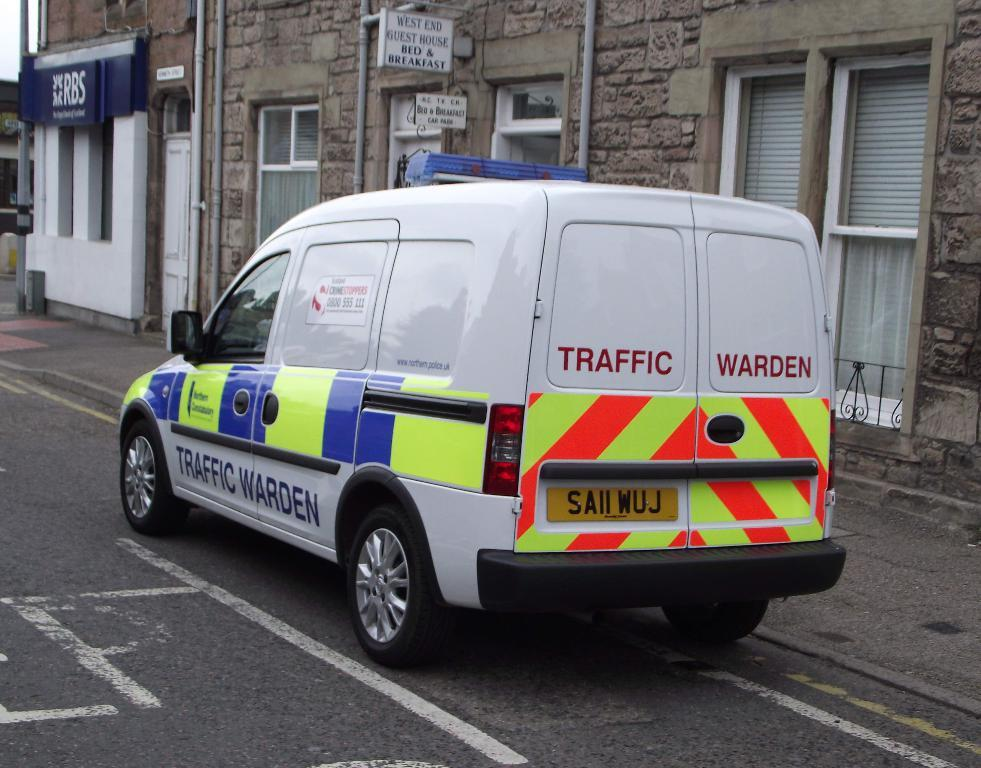<image>
Relay a brief, clear account of the picture shown. a white van with the words traffic warden printed on the back doors. 